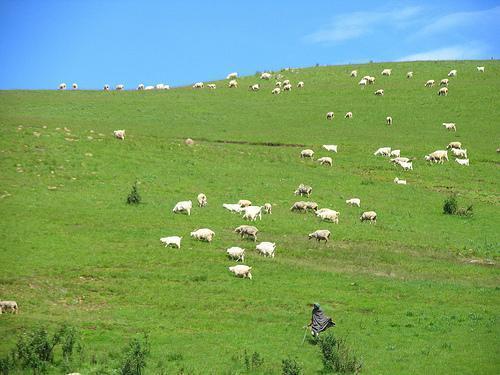How many people are in the picture?
Give a very brief answer. 1. 